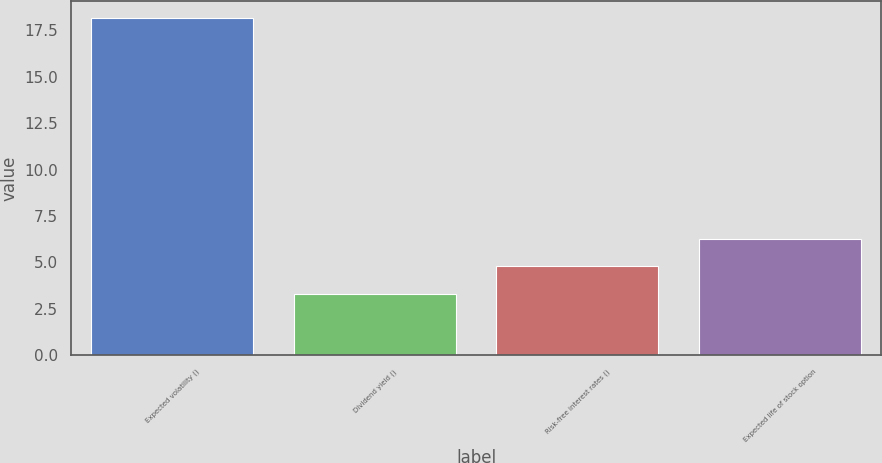Convert chart. <chart><loc_0><loc_0><loc_500><loc_500><bar_chart><fcel>Expected volatility ()<fcel>Dividend yield ()<fcel>Risk-free interest rates ()<fcel>Expected life of stock option<nl><fcel>18.16<fcel>3.3<fcel>4.79<fcel>6.28<nl></chart> 